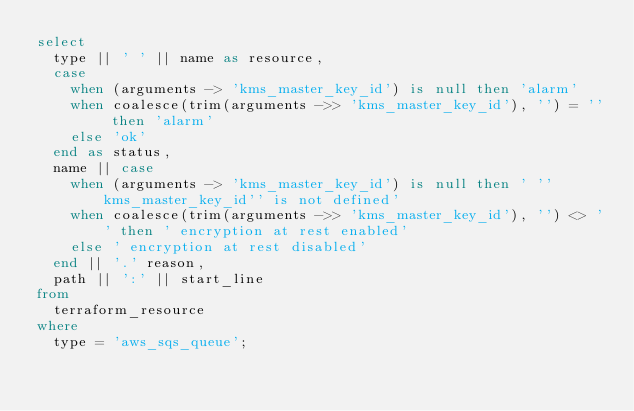<code> <loc_0><loc_0><loc_500><loc_500><_SQL_>select
  type || ' ' || name as resource,
  case
    when (arguments -> 'kms_master_key_id') is null then 'alarm'
    when coalesce(trim(arguments ->> 'kms_master_key_id'), '') = '' then 'alarm'
    else 'ok'
  end as status,
  name || case
    when (arguments -> 'kms_master_key_id') is null then ' ''kms_master_key_id'' is not defined'
    when coalesce(trim(arguments ->> 'kms_master_key_id'), '') <> '' then ' encryption at rest enabled'
    else ' encryption at rest disabled'
  end || '.' reason,
  path || ':' || start_line
from
  terraform_resource
where
  type = 'aws_sqs_queue';</code> 